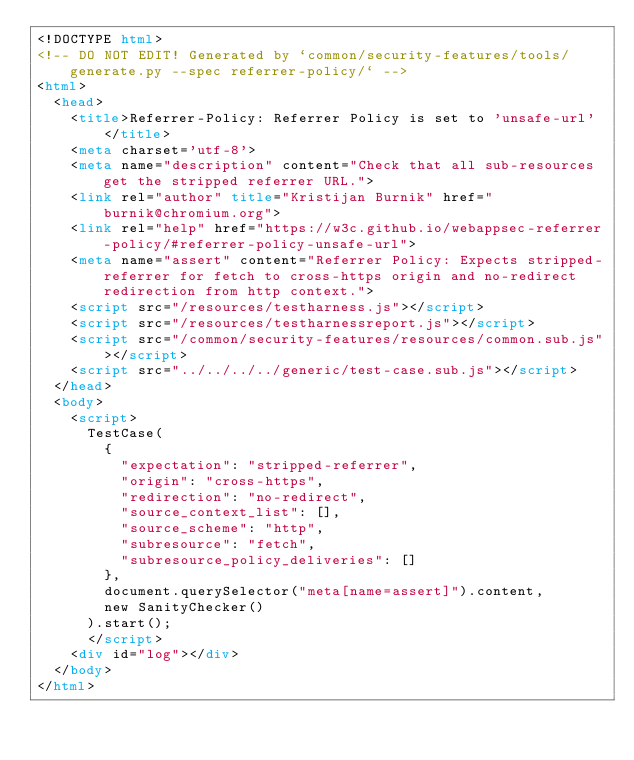<code> <loc_0><loc_0><loc_500><loc_500><_HTML_><!DOCTYPE html>
<!-- DO NOT EDIT! Generated by `common/security-features/tools/generate.py --spec referrer-policy/` -->
<html>
  <head>
    <title>Referrer-Policy: Referrer Policy is set to 'unsafe-url'</title>
    <meta charset='utf-8'>
    <meta name="description" content="Check that all sub-resources get the stripped referrer URL.">
    <link rel="author" title="Kristijan Burnik" href="burnik@chromium.org">
    <link rel="help" href="https://w3c.github.io/webappsec-referrer-policy/#referrer-policy-unsafe-url">
    <meta name="assert" content="Referrer Policy: Expects stripped-referrer for fetch to cross-https origin and no-redirect redirection from http context.">
    <script src="/resources/testharness.js"></script>
    <script src="/resources/testharnessreport.js"></script>
    <script src="/common/security-features/resources/common.sub.js"></script>
    <script src="../../../../generic/test-case.sub.js"></script>
  </head>
  <body>
    <script>
      TestCase(
        {
          "expectation": "stripped-referrer",
          "origin": "cross-https",
          "redirection": "no-redirect",
          "source_context_list": [],
          "source_scheme": "http",
          "subresource": "fetch",
          "subresource_policy_deliveries": []
        },
        document.querySelector("meta[name=assert]").content,
        new SanityChecker()
      ).start();
      </script>
    <div id="log"></div>
  </body>
</html>
</code> 